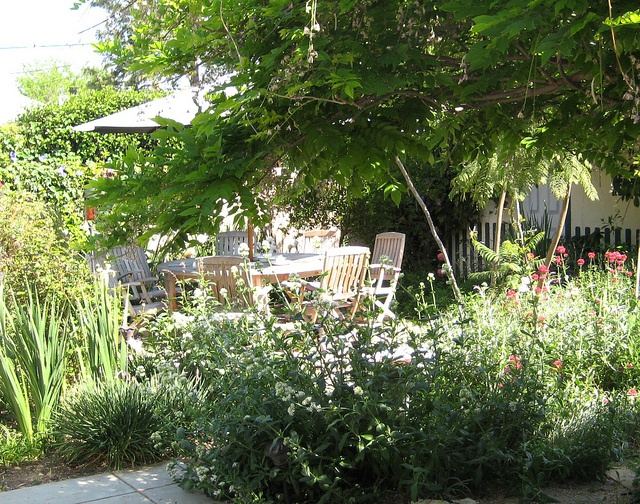Describe the objects in this image and their specific colors. I can see umbrella in white, gray, darkgray, and darkgreen tones, chair in white, tan, ivory, gray, and darkgray tones, dining table in white, darkgray, and gray tones, chair in white, ivory, tan, and darkgray tones, and chair in white, black, gray, and darkgreen tones in this image. 